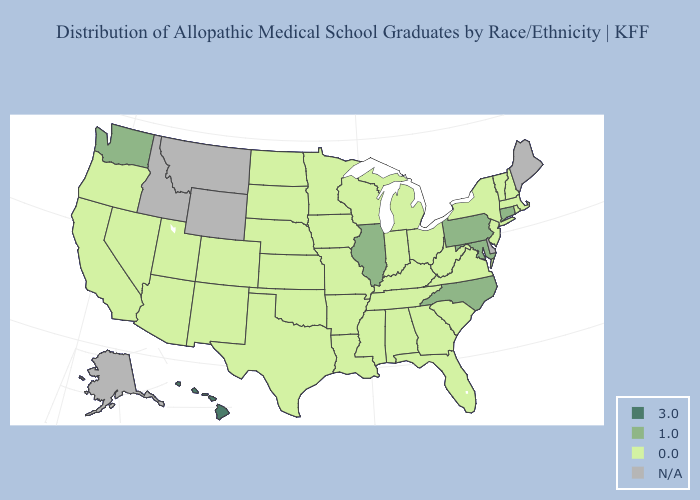Name the states that have a value in the range N/A?
Concise answer only. Alaska, Delaware, Idaho, Maine, Montana, Wyoming. What is the highest value in states that border Missouri?
Concise answer only. 1.0. What is the value of Nebraska?
Give a very brief answer. 0.0. What is the value of Wyoming?
Concise answer only. N/A. Name the states that have a value in the range 3.0?
Answer briefly. Hawaii. Name the states that have a value in the range 1.0?
Be succinct. Connecticut, Illinois, Maryland, North Carolina, Pennsylvania, Washington. Does Nebraska have the lowest value in the USA?
Write a very short answer. Yes. Which states have the highest value in the USA?
Be succinct. Hawaii. Does Hawaii have the highest value in the USA?
Quick response, please. Yes. Name the states that have a value in the range 3.0?
Write a very short answer. Hawaii. What is the value of Idaho?
Answer briefly. N/A. Name the states that have a value in the range 1.0?
Give a very brief answer. Connecticut, Illinois, Maryland, North Carolina, Pennsylvania, Washington. Does the first symbol in the legend represent the smallest category?
Write a very short answer. No. 